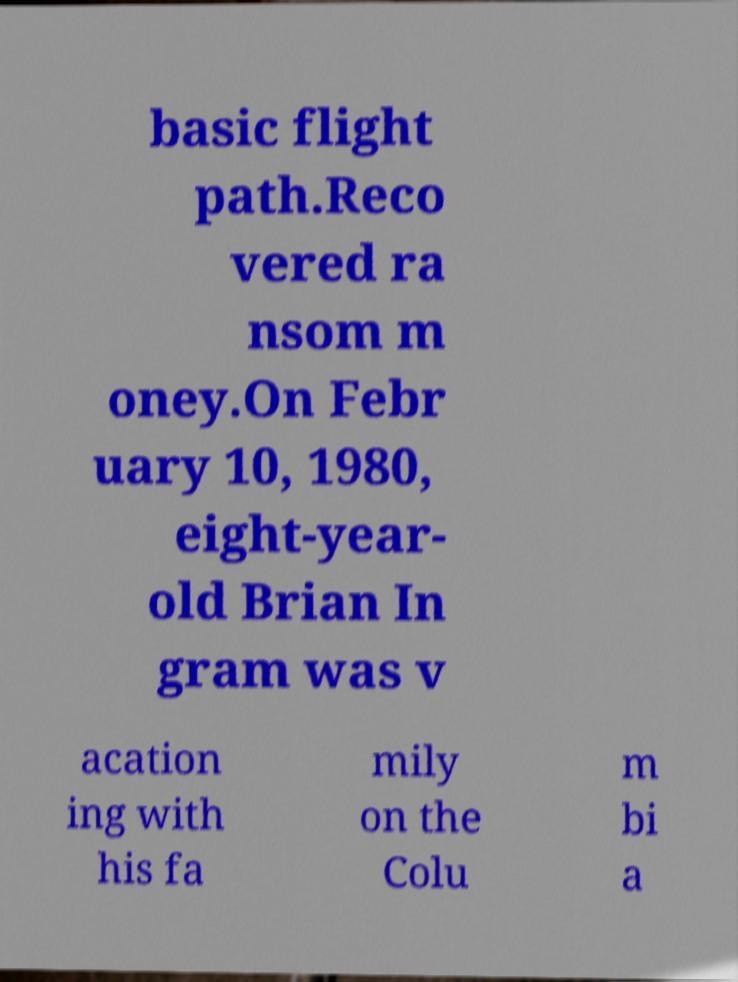Please read and relay the text visible in this image. What does it say? basic flight path.Reco vered ra nsom m oney.On Febr uary 10, 1980, eight-year- old Brian In gram was v acation ing with his fa mily on the Colu m bi a 